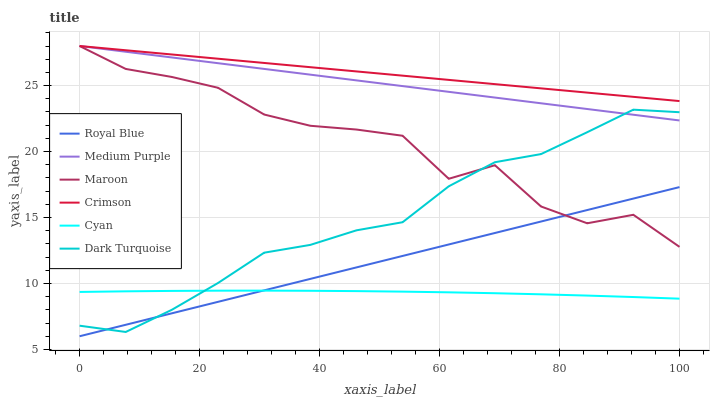Does Maroon have the minimum area under the curve?
Answer yes or no. No. Does Maroon have the maximum area under the curve?
Answer yes or no. No. Is Medium Purple the smoothest?
Answer yes or no. No. Is Medium Purple the roughest?
Answer yes or no. No. Does Maroon have the lowest value?
Answer yes or no. No. Does Royal Blue have the highest value?
Answer yes or no. No. Is Dark Turquoise less than Crimson?
Answer yes or no. Yes. Is Crimson greater than Royal Blue?
Answer yes or no. Yes. Does Dark Turquoise intersect Crimson?
Answer yes or no. No. 